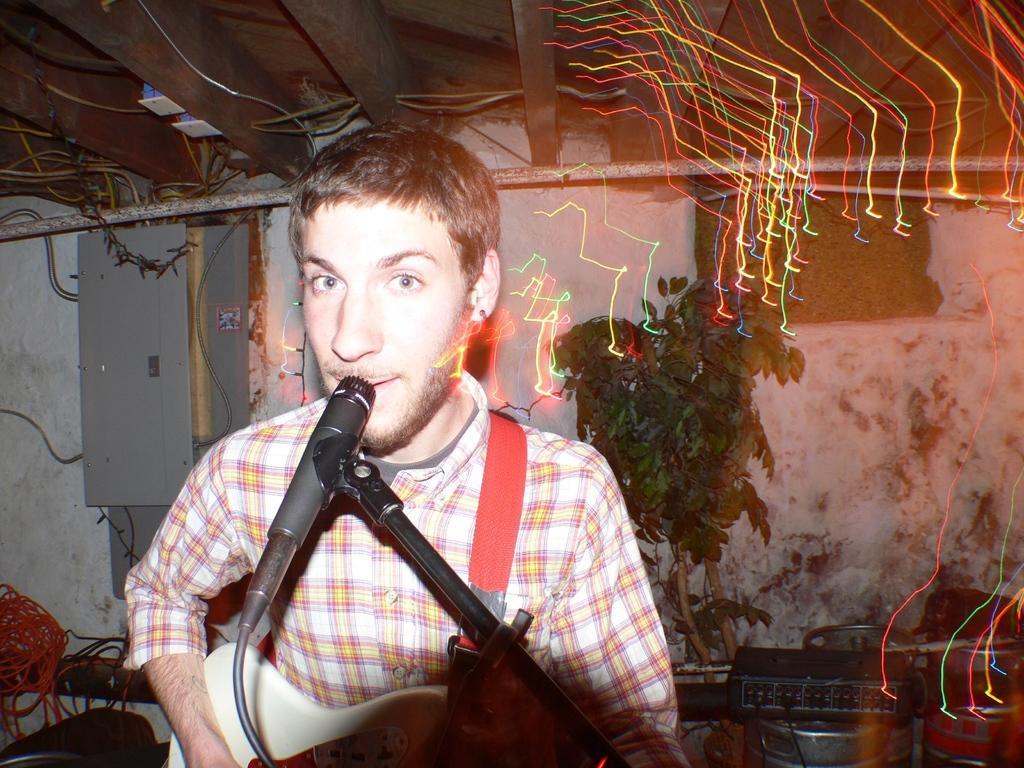In one or two sentences, can you explain what this image depicts? A man is singing in the microphone and also playing the guitar, behind him there is a tree. 